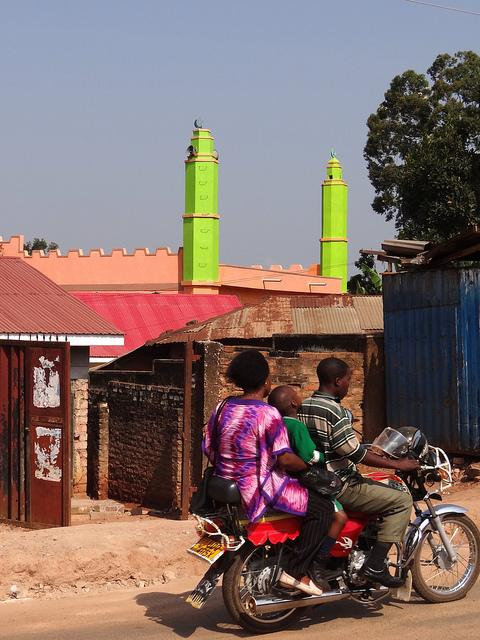Why are three people on the bike? going somewhere 